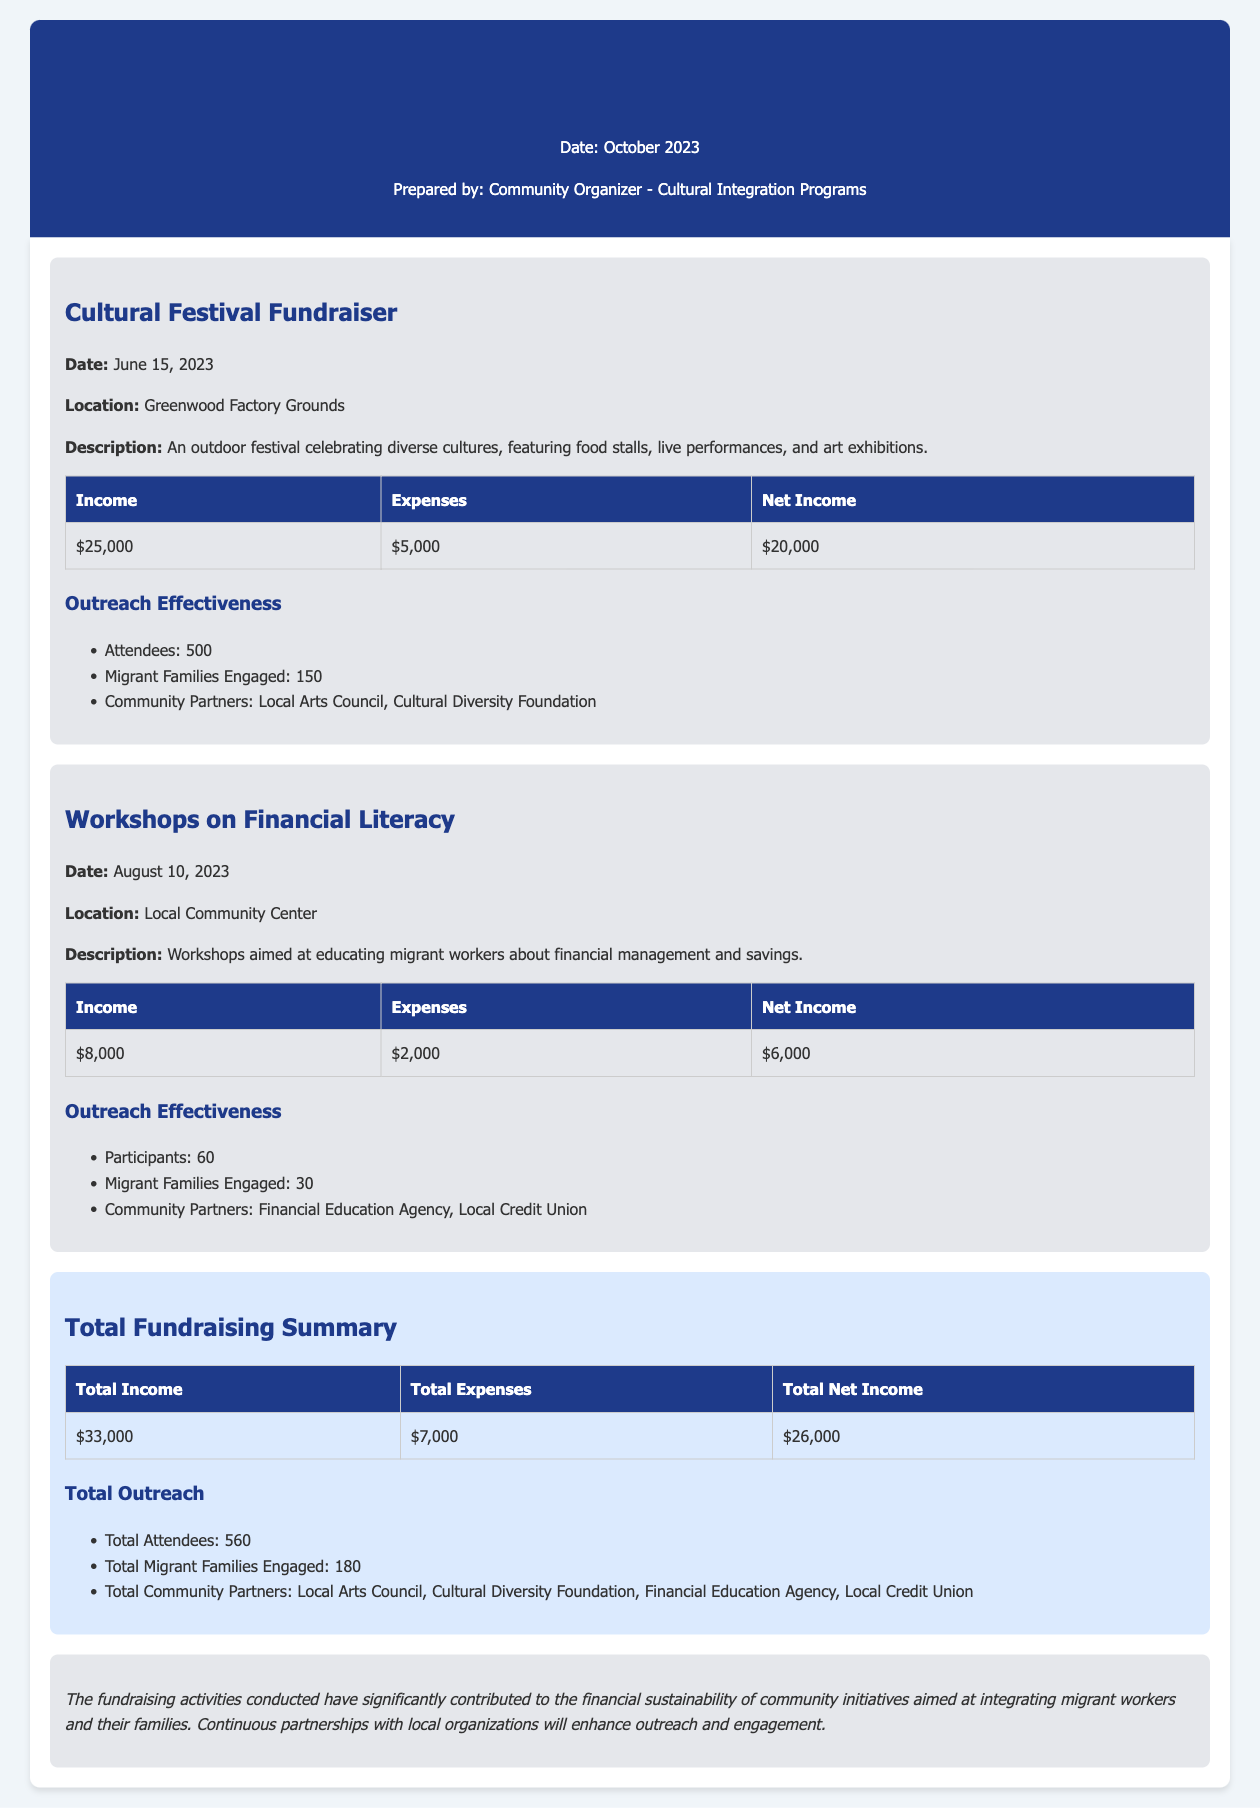what was the date of the Cultural Festival Fundraiser? The date of the Cultural Festival Fundraiser is mentioned in the document as June 15, 2023.
Answer: June 15, 2023 what is the total net income from the fundraising activities? The total net income is derived from the summary table, which states the total net income as $26,000.
Answer: $26,000 how many community partners were involved in total? The total number of community partners is mentioned in the document, which lists four partners.
Answer: 4 what was the income generated from the Workshops on Financial Literacy? The income from the Workshops on Financial Literacy is listed in the relevant section as $8,000.
Answer: $8,000 how many migrant families were engaged during the Cultural Festival Fundraiser? The number of migrant families engaged during the Cultural Festival Fundraiser is stated as 150 in the outreach effectiveness section.
Answer: 150 what is the total number of attendees for both activities? The total attendees are summed up in the summary section, stating a total of 560 attendees.
Answer: 560 what was the location of the Workshops on Financial Literacy? The document specifies the location as the Local Community Center for the Workshops on Financial Literacy.
Answer: Local Community Center what was the expense amount for the Cultural Festival Fundraiser? The expenses for the Cultural Festival Fundraiser are provided in the related table as $5,000.
Answer: $5,000 